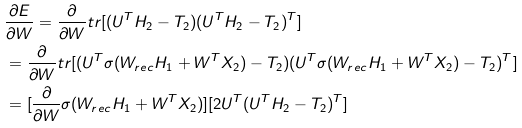<formula> <loc_0><loc_0><loc_500><loc_500>& \frac { \partial E } { \partial W } = \frac { \partial } { \partial W } t r [ ( U ^ { T } H _ { 2 } - T _ { 2 } ) ( U ^ { T } H _ { 2 } - T _ { 2 } ) ^ { T } ] \\ & = \frac { \partial } { \partial W } t r [ ( U ^ { T } \sigma ( W _ { r e c } H _ { 1 } + W ^ { T } X _ { 2 } ) - T _ { 2 } ) ( U ^ { T } \sigma ( W _ { r e c } H _ { 1 } + W ^ { T } X _ { 2 } ) - T _ { 2 } ) ^ { T } ] \\ & = [ \frac { \partial } { \partial W } \sigma ( W _ { r e c } H _ { 1 } + W ^ { T } X _ { 2 } ) ] [ 2 U ^ { T } ( U ^ { T } H _ { 2 } - T _ { 2 } ) ^ { T } ]</formula> 